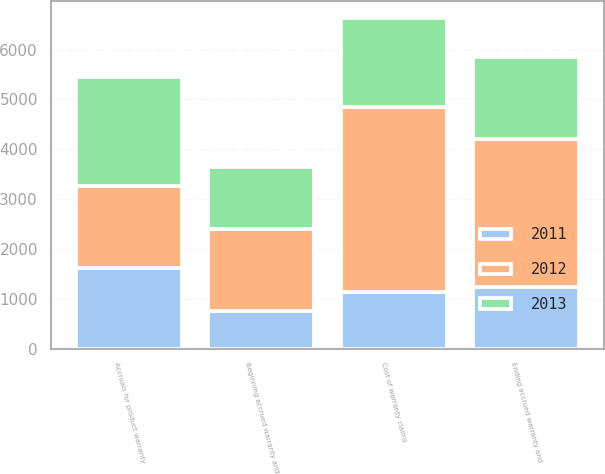<chart> <loc_0><loc_0><loc_500><loc_500><stacked_bar_chart><ecel><fcel>Beginning accrued warranty and<fcel>Cost of warranty claims<fcel>Accruals for product warranty<fcel>Ending accrued warranty and<nl><fcel>2012<fcel>1638<fcel>3703<fcel>1638<fcel>2967<nl><fcel>2013<fcel>1240<fcel>1786<fcel>2184<fcel>1638<nl><fcel>2011<fcel>761<fcel>1147<fcel>1626<fcel>1240<nl></chart> 